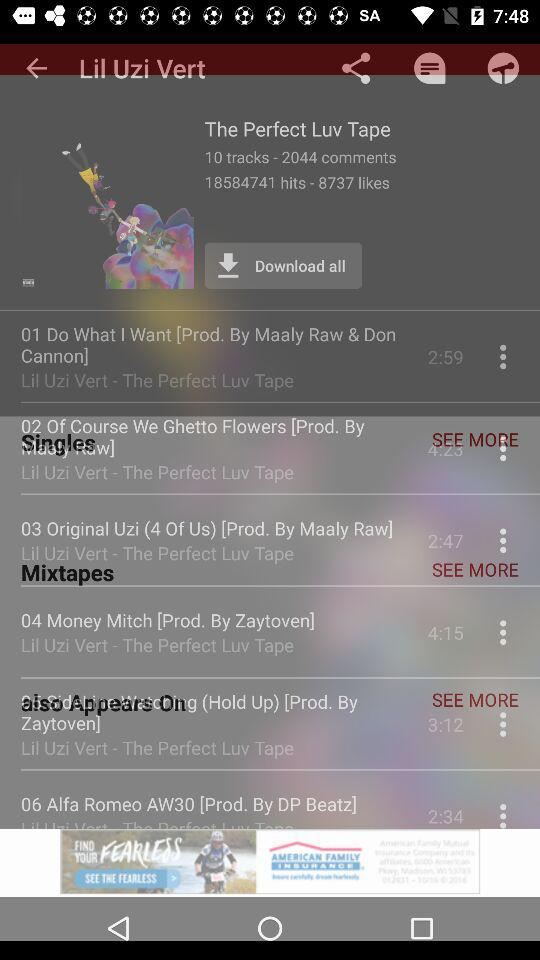How many likes did "The Perfect Luv Tape" get? "The Perfect Luv Tape" got 8737 likes. 